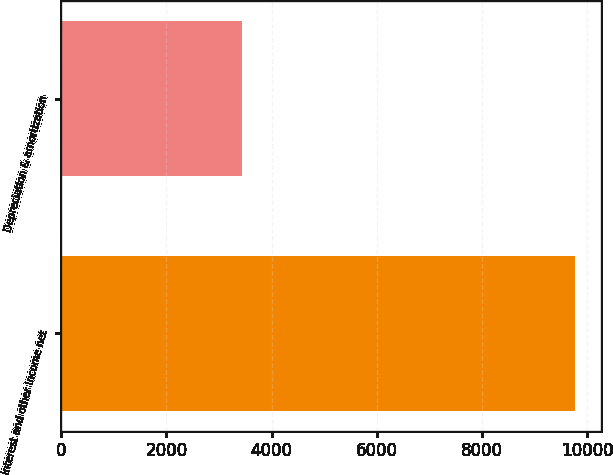Convert chart to OTSL. <chart><loc_0><loc_0><loc_500><loc_500><bar_chart><fcel>Interest and other income net<fcel>Depreciation & amortization<nl><fcel>9775<fcel>3446<nl></chart> 